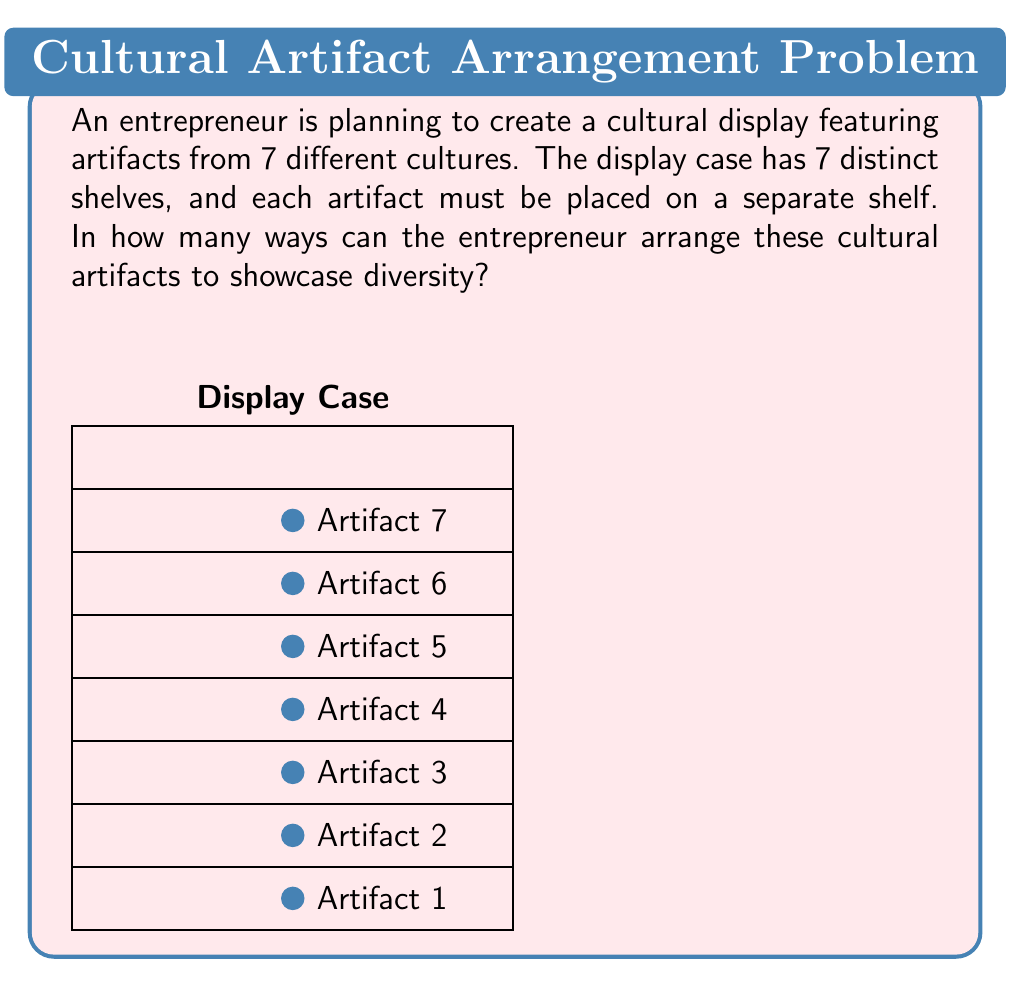Help me with this question. To solve this problem, we need to use the concept of permutations. Here's a step-by-step explanation:

1) We have 7 distinct artifacts and 7 distinct shelves. Each artifact needs to be placed on a shelf, and no shelf can be left empty.

2) This scenario is equivalent to arranging 7 distinct objects in 7 distinct positions, which is a classic permutation problem.

3) The number of ways to arrange n distinct objects in n positions is given by the factorial of n, denoted as n!.

4) In this case, n = 7, so we need to calculate 7!.

5) Let's expand this:
   $$7! = 7 \times 6 \times 5 \times 4 \times 3 \times 2 \times 1$$

6) Calculating this:
   $$7! = 5040$$

Therefore, there are 5040 different ways to arrange the 7 cultural artifacts on the 7 shelves of the display case.
Answer: 5040 